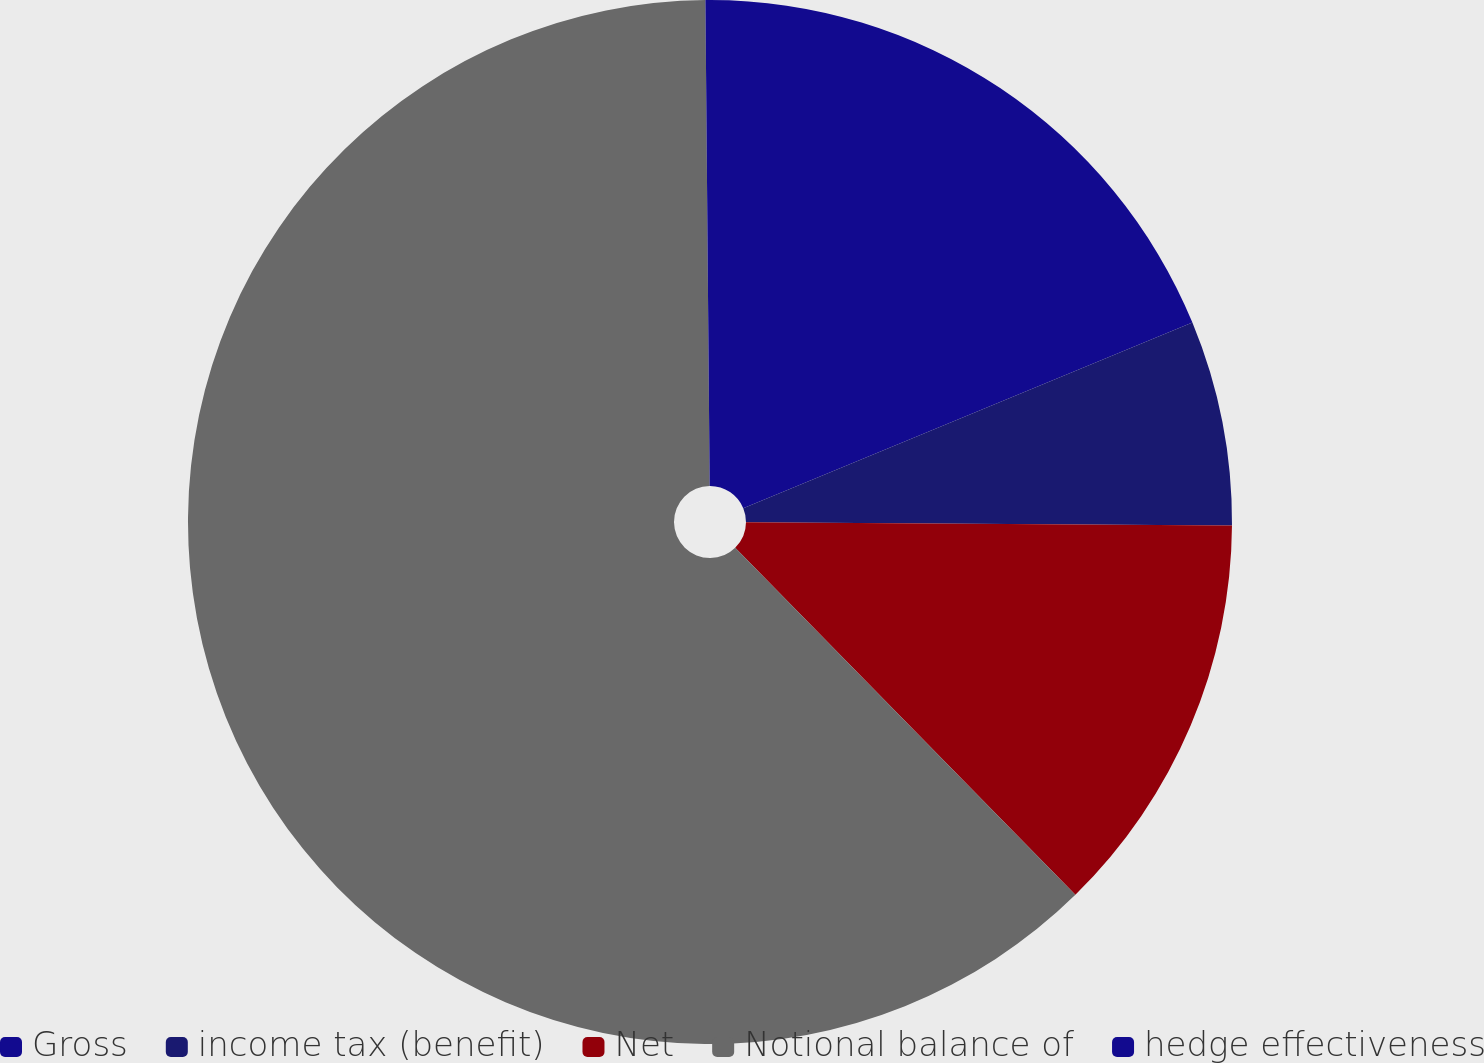Convert chart. <chart><loc_0><loc_0><loc_500><loc_500><pie_chart><fcel>Gross<fcel>income tax (benefit)<fcel>Net<fcel>Notional balance of<fcel>hedge effectiveness<nl><fcel>18.76%<fcel>6.35%<fcel>12.55%<fcel>62.2%<fcel>0.14%<nl></chart> 